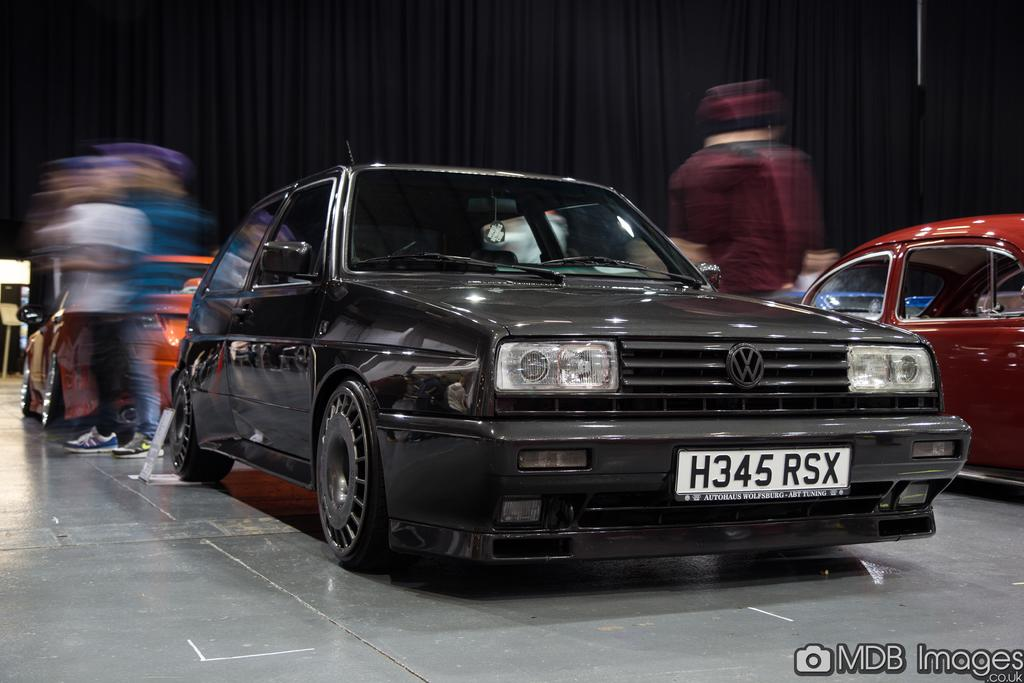How many cars are visible in the image? There are two cars in the image. What else can be seen in the image besides the cars? There are people standing in the image. What color is the curtain in the background of the image? The curtain is black. Where is the watermark located in the image? The watermark is in the bottom right corner of the image. How many letters are being carried by the bee in the image? There is no bee or letters present in the image. What type of fruit is being held by the person in the image? There is no fruit visible in the image. 